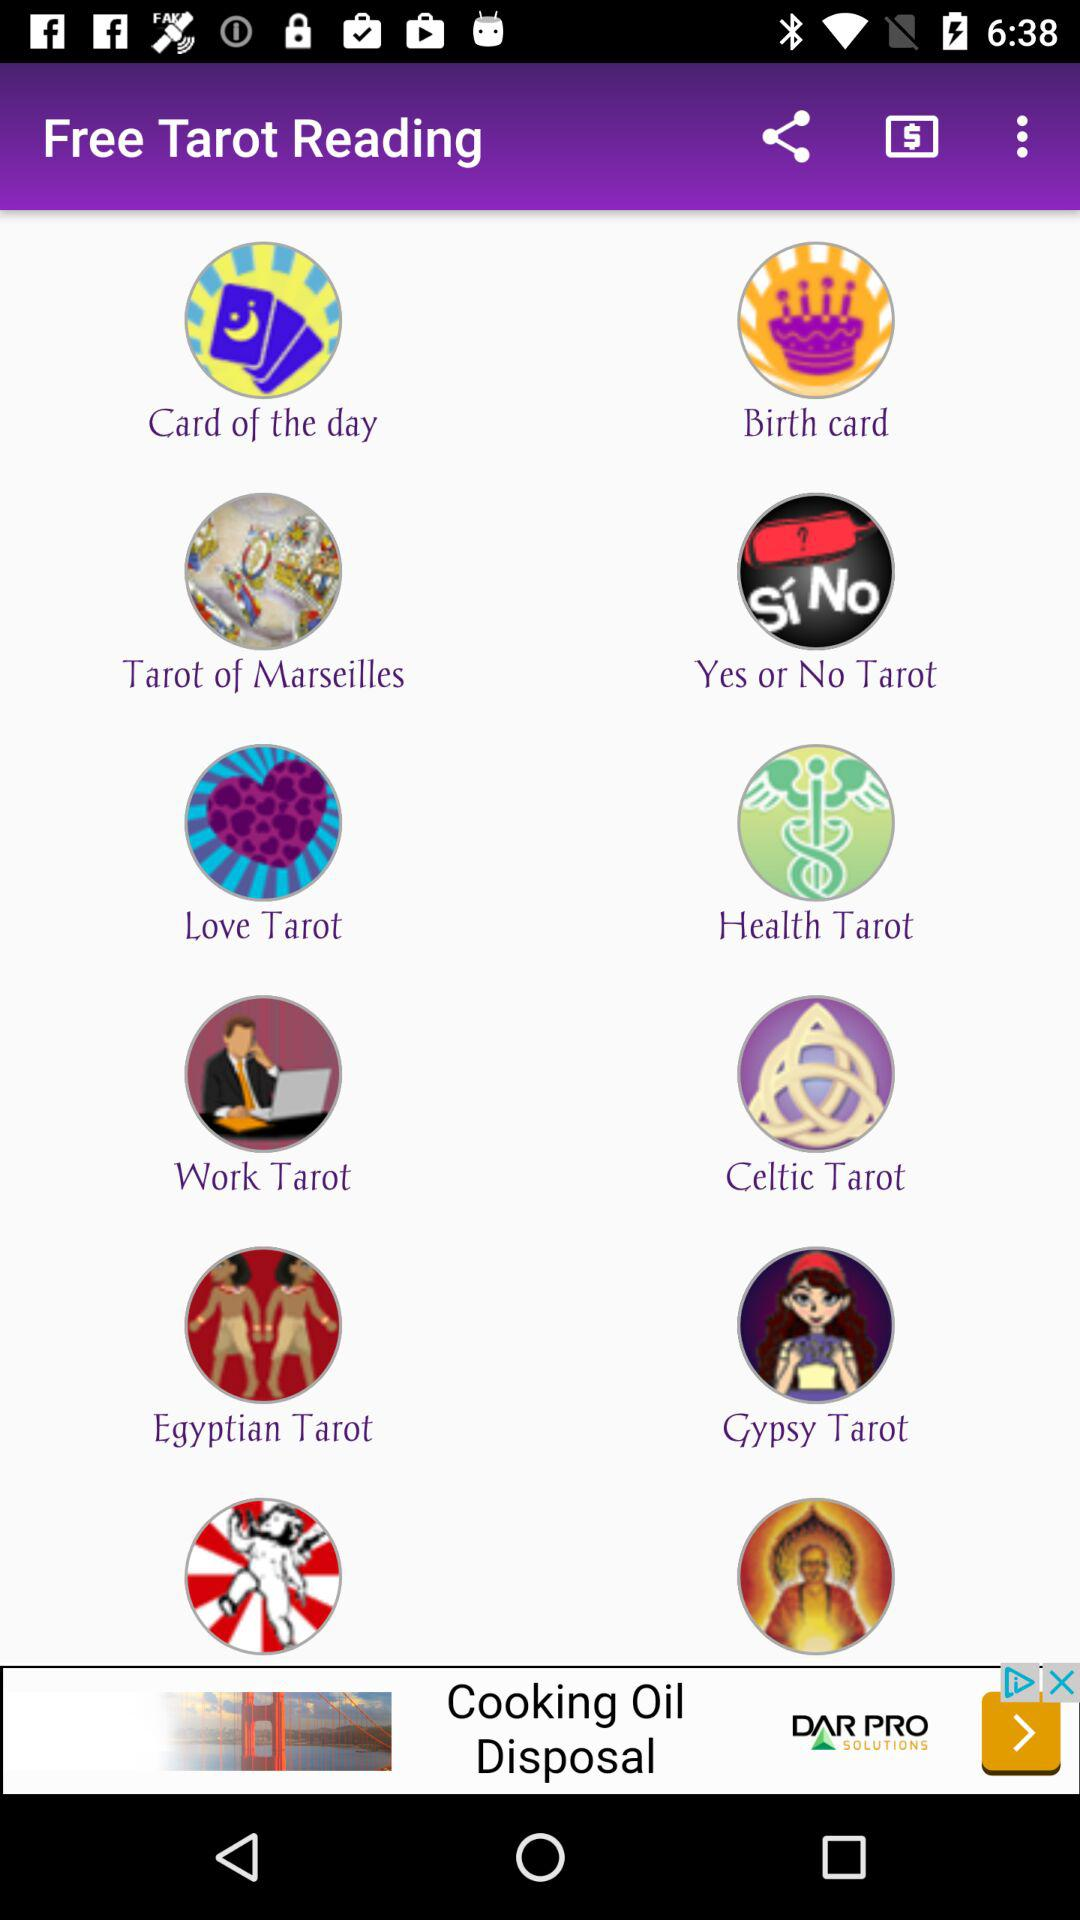What are the types of tarot reading cards that I can read? The types of tarot reading cards that I read are "Card of the day", "Birth card", "Tarot of Marseilles", "Yes or No Tarot", "Love Tarot", "Health Tarot", "Work Tarot", "Celtic Tarot", "Egyptian Tarot" and "Gypsy Tarot". 